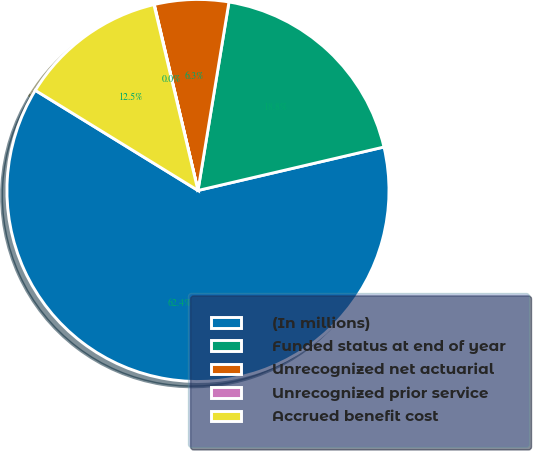<chart> <loc_0><loc_0><loc_500><loc_500><pie_chart><fcel>(In millions)<fcel>Funded status at end of year<fcel>Unrecognized net actuarial<fcel>Unrecognized prior service<fcel>Accrued benefit cost<nl><fcel>62.43%<fcel>18.75%<fcel>6.27%<fcel>0.03%<fcel>12.51%<nl></chart> 